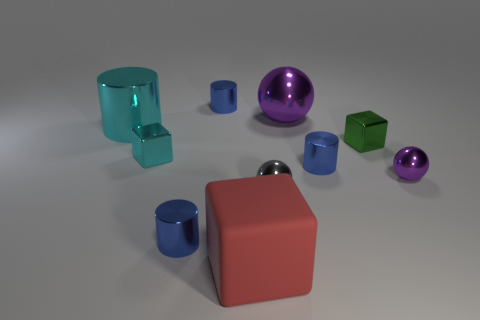Are there any other things that are made of the same material as the red thing?
Ensure brevity in your answer.  No. Are there any metallic things of the same color as the matte cube?
Make the answer very short. No. The green shiny thing that is the same size as the gray object is what shape?
Your answer should be compact. Cube. The small cube that is to the left of the green cube is what color?
Your answer should be very brief. Cyan. There is a large thing that is left of the red rubber thing; are there any cyan metal objects in front of it?
Your answer should be compact. Yes. How many objects are tiny blue objects in front of the small purple sphere or small shiny cylinders?
Give a very brief answer. 3. Is there anything else that has the same size as the cyan cylinder?
Give a very brief answer. Yes. What material is the blue object that is to the left of the small blue object behind the large cyan metallic cylinder?
Give a very brief answer. Metal. Are there the same number of purple objects that are to the right of the red rubber object and small shiny cubes in front of the gray thing?
Ensure brevity in your answer.  No. What number of things are blocks to the left of the matte object or small metallic things to the left of the small purple metallic sphere?
Offer a terse response. 6. 